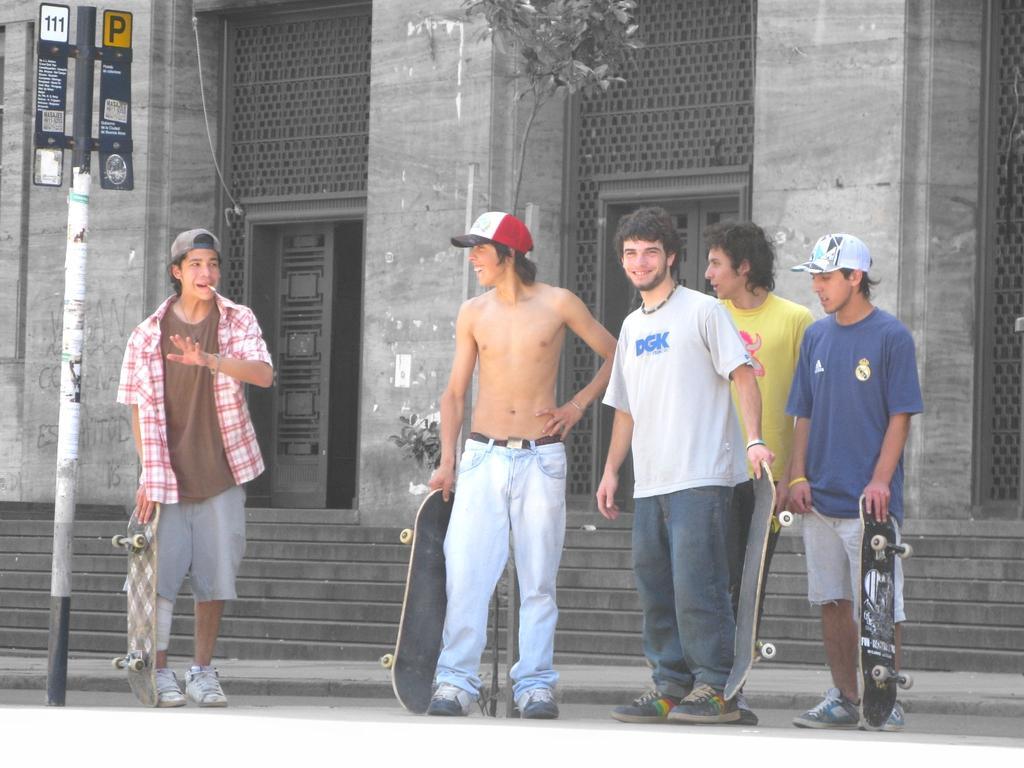Could you give a brief overview of what you see in this image? In this picture we can see five persons are standing, four persons in the front are holding skateboards, on the left side there is a pole and boards, in the background we can see a building and a tree. 